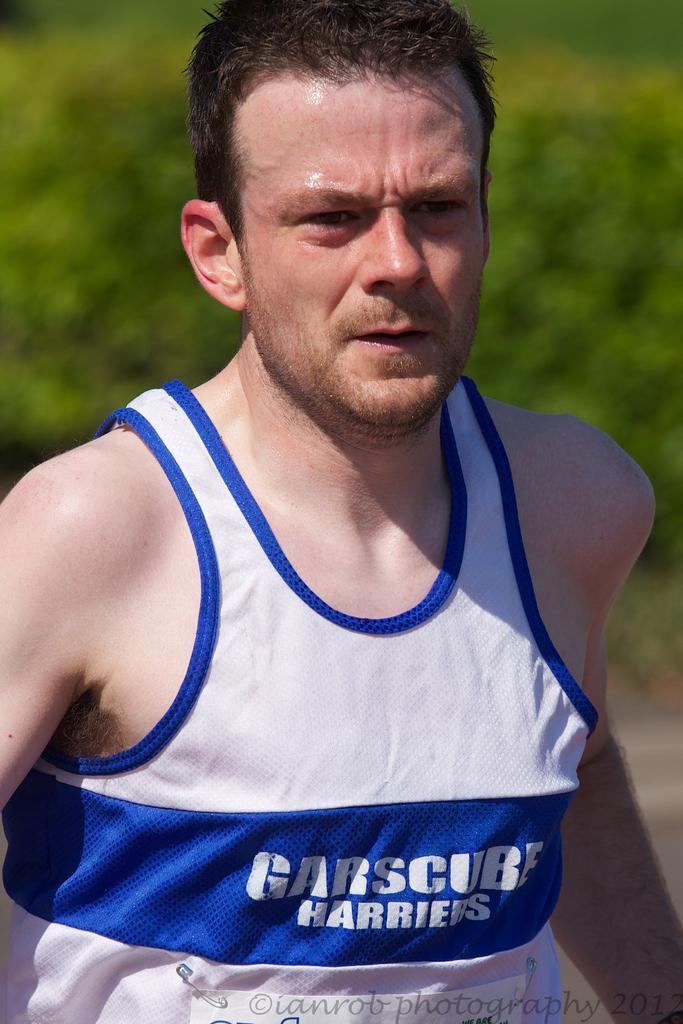How would you summarize this image in a sentence or two? In this image there is a man who is wearing the sleeve less bunny, to which there is a badge which is attached to the shirt with the clips. In the background there are trees. 